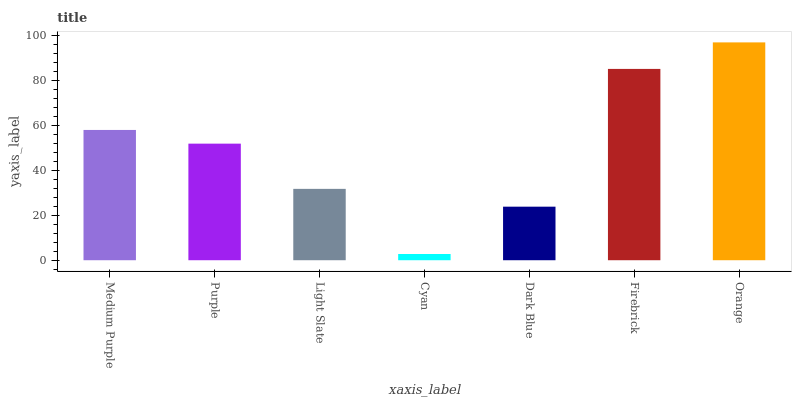Is Cyan the minimum?
Answer yes or no. Yes. Is Orange the maximum?
Answer yes or no. Yes. Is Purple the minimum?
Answer yes or no. No. Is Purple the maximum?
Answer yes or no. No. Is Medium Purple greater than Purple?
Answer yes or no. Yes. Is Purple less than Medium Purple?
Answer yes or no. Yes. Is Purple greater than Medium Purple?
Answer yes or no. No. Is Medium Purple less than Purple?
Answer yes or no. No. Is Purple the high median?
Answer yes or no. Yes. Is Purple the low median?
Answer yes or no. Yes. Is Medium Purple the high median?
Answer yes or no. No. Is Orange the low median?
Answer yes or no. No. 